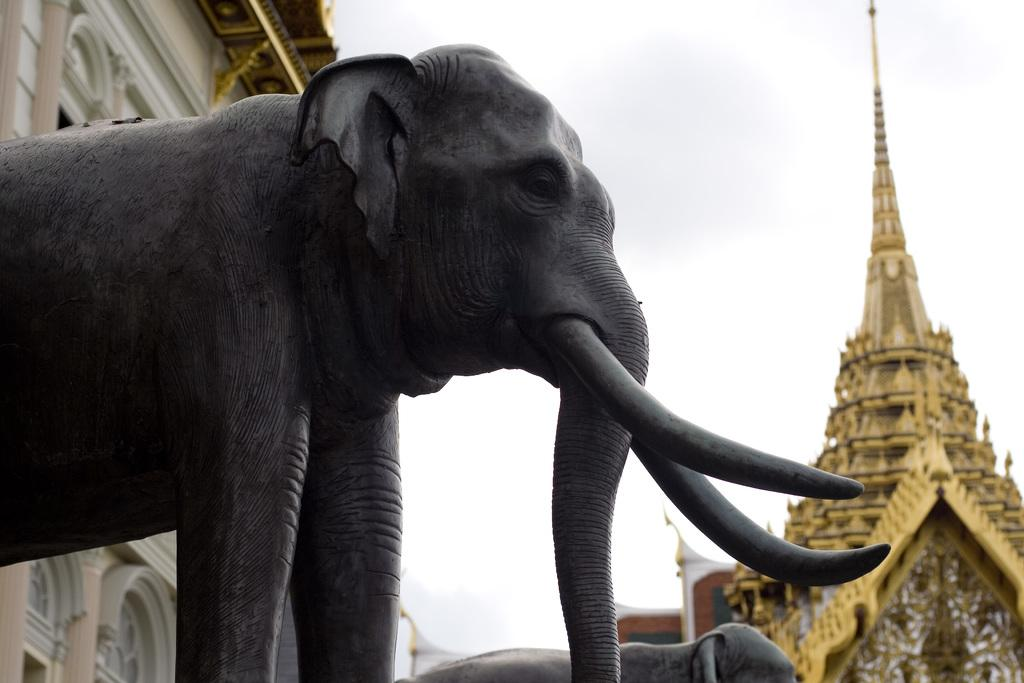What is the main subject of the image? There is a statue of an elephant in the image. What can be seen in the background of the image? There is a building and a golden color tower in the background of the image. Can you tell me how many people are trying to join the appliance in the image? There are no people or appliances present in the image, so this question cannot be answered. 